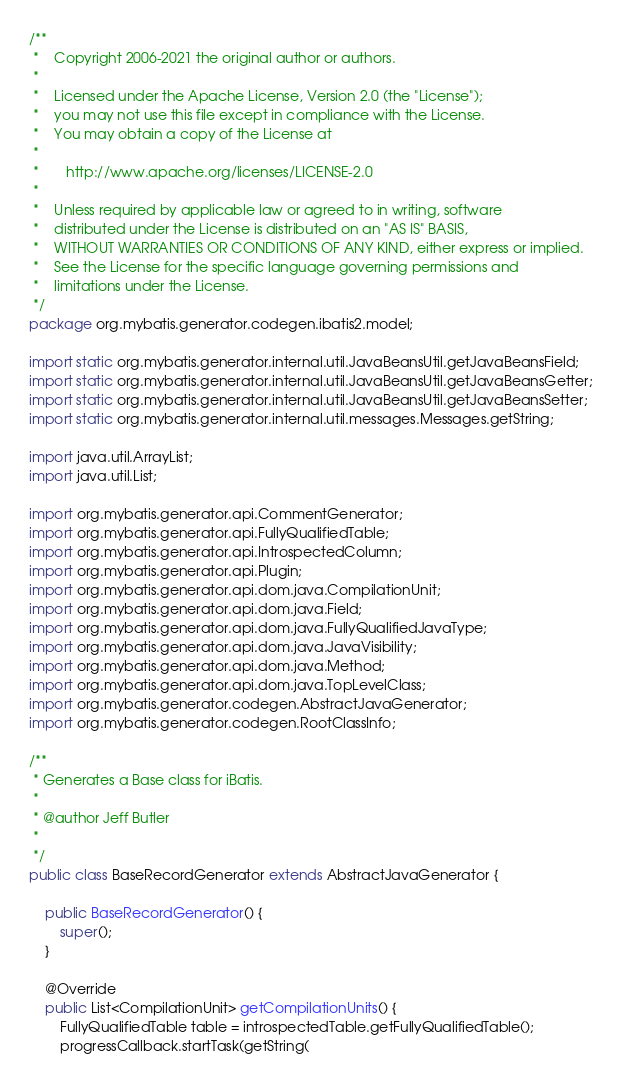<code> <loc_0><loc_0><loc_500><loc_500><_Java_>/**
 *    Copyright 2006-2021 the original author or authors.
 *
 *    Licensed under the Apache License, Version 2.0 (the "License");
 *    you may not use this file except in compliance with the License.
 *    You may obtain a copy of the License at
 *
 *       http://www.apache.org/licenses/LICENSE-2.0
 *
 *    Unless required by applicable law or agreed to in writing, software
 *    distributed under the License is distributed on an "AS IS" BASIS,
 *    WITHOUT WARRANTIES OR CONDITIONS OF ANY KIND, either express or implied.
 *    See the License for the specific language governing permissions and
 *    limitations under the License.
 */
package org.mybatis.generator.codegen.ibatis2.model;

import static org.mybatis.generator.internal.util.JavaBeansUtil.getJavaBeansField;
import static org.mybatis.generator.internal.util.JavaBeansUtil.getJavaBeansGetter;
import static org.mybatis.generator.internal.util.JavaBeansUtil.getJavaBeansSetter;
import static org.mybatis.generator.internal.util.messages.Messages.getString;

import java.util.ArrayList;
import java.util.List;

import org.mybatis.generator.api.CommentGenerator;
import org.mybatis.generator.api.FullyQualifiedTable;
import org.mybatis.generator.api.IntrospectedColumn;
import org.mybatis.generator.api.Plugin;
import org.mybatis.generator.api.dom.java.CompilationUnit;
import org.mybatis.generator.api.dom.java.Field;
import org.mybatis.generator.api.dom.java.FullyQualifiedJavaType;
import org.mybatis.generator.api.dom.java.JavaVisibility;
import org.mybatis.generator.api.dom.java.Method;
import org.mybatis.generator.api.dom.java.TopLevelClass;
import org.mybatis.generator.codegen.AbstractJavaGenerator;
import org.mybatis.generator.codegen.RootClassInfo;

/**
 * Generates a Base class for iBatis.
 * 
 * @author Jeff Butler
 * 
 */
public class BaseRecordGenerator extends AbstractJavaGenerator {

    public BaseRecordGenerator() {
        super();
    }

    @Override
    public List<CompilationUnit> getCompilationUnits() {
        FullyQualifiedTable table = introspectedTable.getFullyQualifiedTable();
        progressCallback.startTask(getString(</code> 